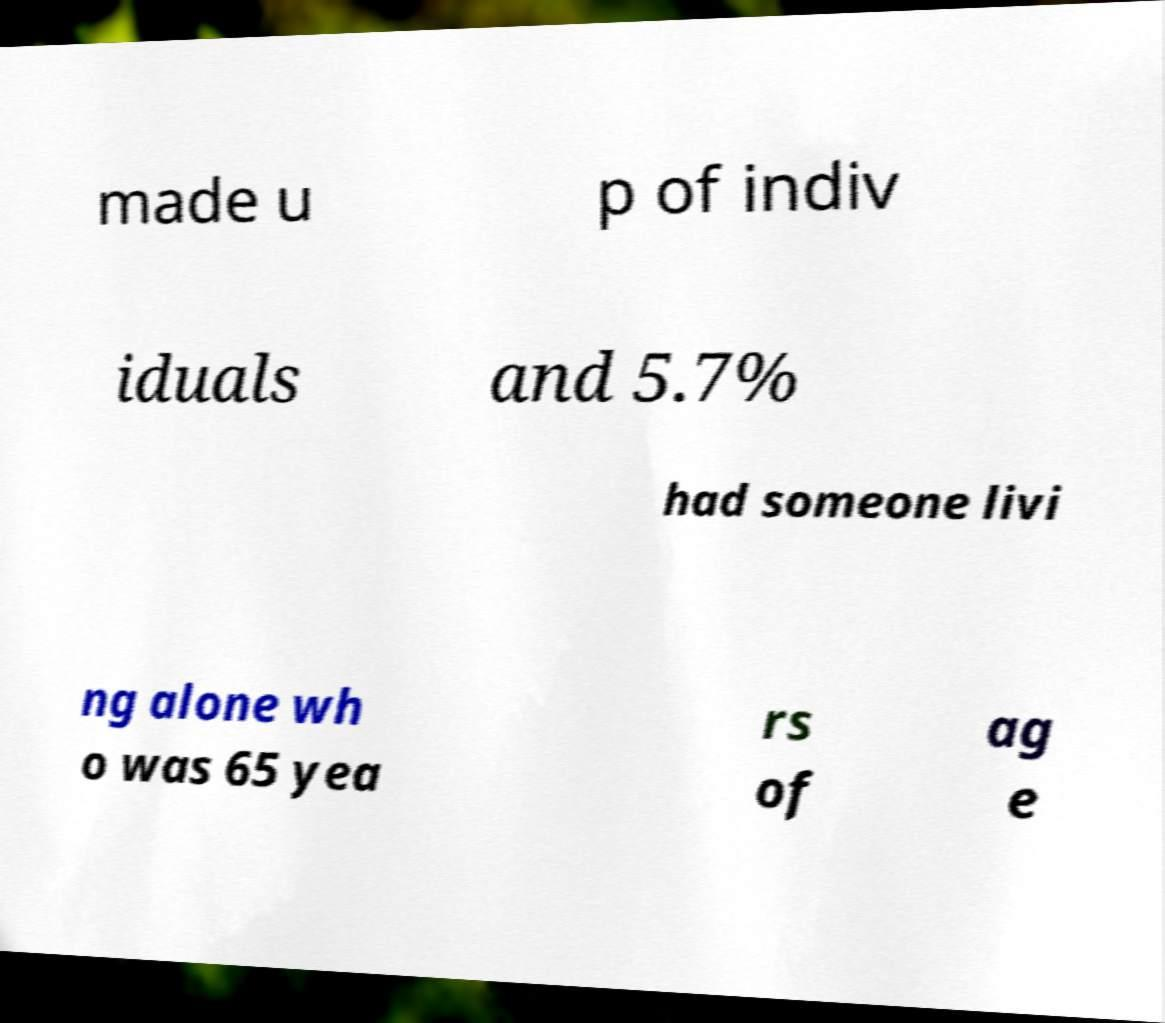Please identify and transcribe the text found in this image. made u p of indiv iduals and 5.7% had someone livi ng alone wh o was 65 yea rs of ag e 